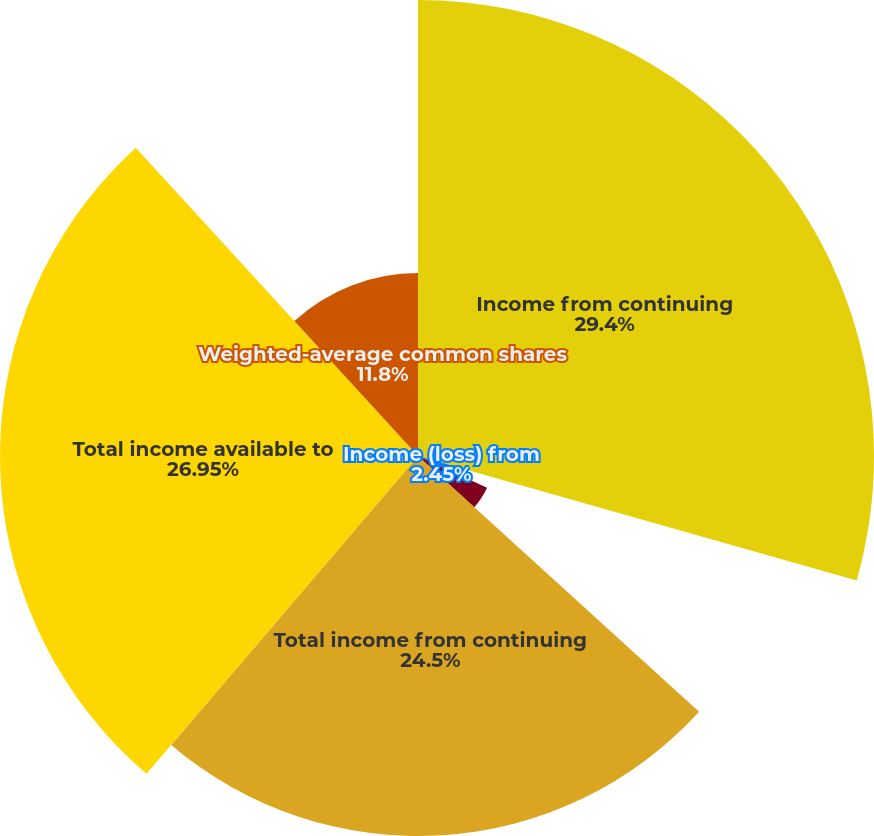<chart> <loc_0><loc_0><loc_500><loc_500><pie_chart><fcel>Income from continuing<fcel>Income (loss) from<fcel>Undistributed earnings<fcel>Total income from continuing<fcel>Total income available to<fcel>Weighted-average common shares<fcel>Net income<nl><fcel>29.4%<fcel>2.45%<fcel>4.9%<fcel>24.5%<fcel>26.95%<fcel>11.8%<fcel>0.0%<nl></chart> 